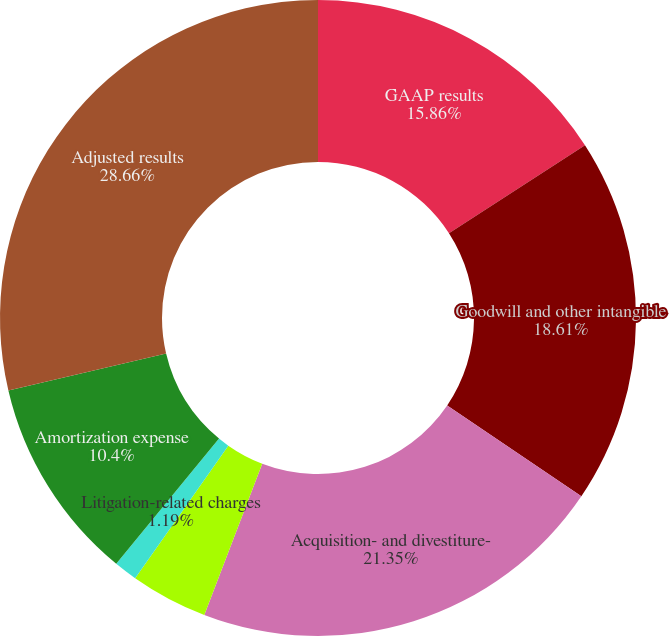Convert chart to OTSL. <chart><loc_0><loc_0><loc_500><loc_500><pie_chart><fcel>GAAP results<fcel>Goodwill and other intangible<fcel>Acquisition- and divestiture-<fcel>Restructuring-related charges<fcel>Litigation-related charges<fcel>Amortization expense<fcel>Adjusted results<nl><fcel>15.86%<fcel>18.61%<fcel>21.35%<fcel>3.93%<fcel>1.19%<fcel>10.4%<fcel>28.66%<nl></chart> 